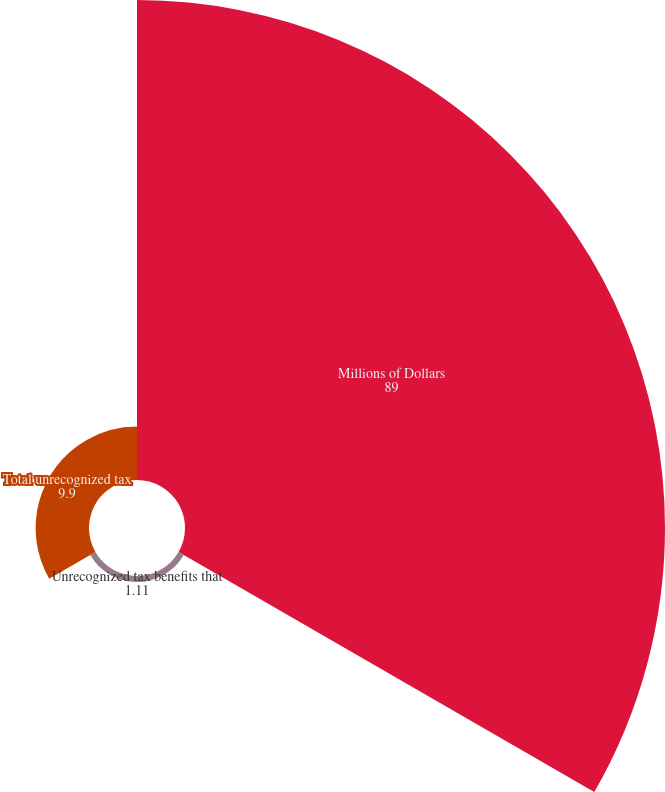<chart> <loc_0><loc_0><loc_500><loc_500><pie_chart><fcel>Millions of Dollars<fcel>Unrecognized tax benefits that<fcel>Total unrecognized tax<nl><fcel>89.0%<fcel>1.11%<fcel>9.9%<nl></chart> 